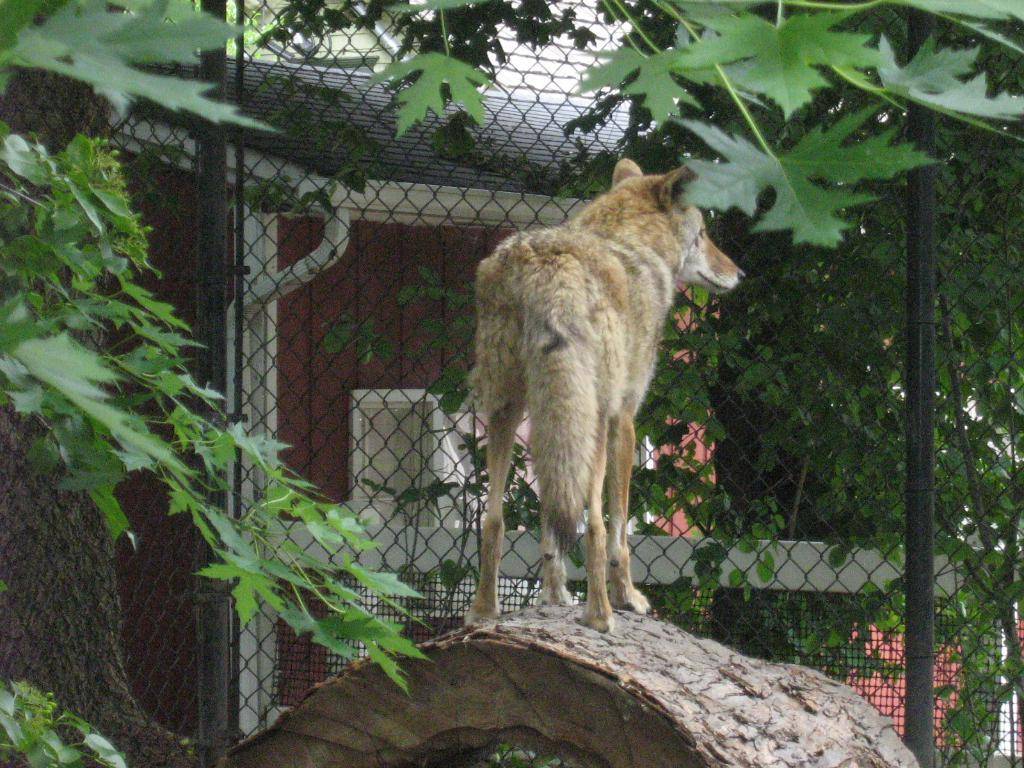What type of object can be seen in the image made of wood? There is a wooden branch in the image. What is the animal standing in the image? The animal standing in the image is not specified, but it is present. What type of vegetation is visible in the image? There are leaves in the image. What type of barrier can be seen in the image? There is fencing in the image. What type of structure is visible in the background of the image? There is a house in the image. What shape is the account in the image? There is no account present in the image; it is a scene featuring a wooden branch, an animal, leaves, fencing, and a house. 